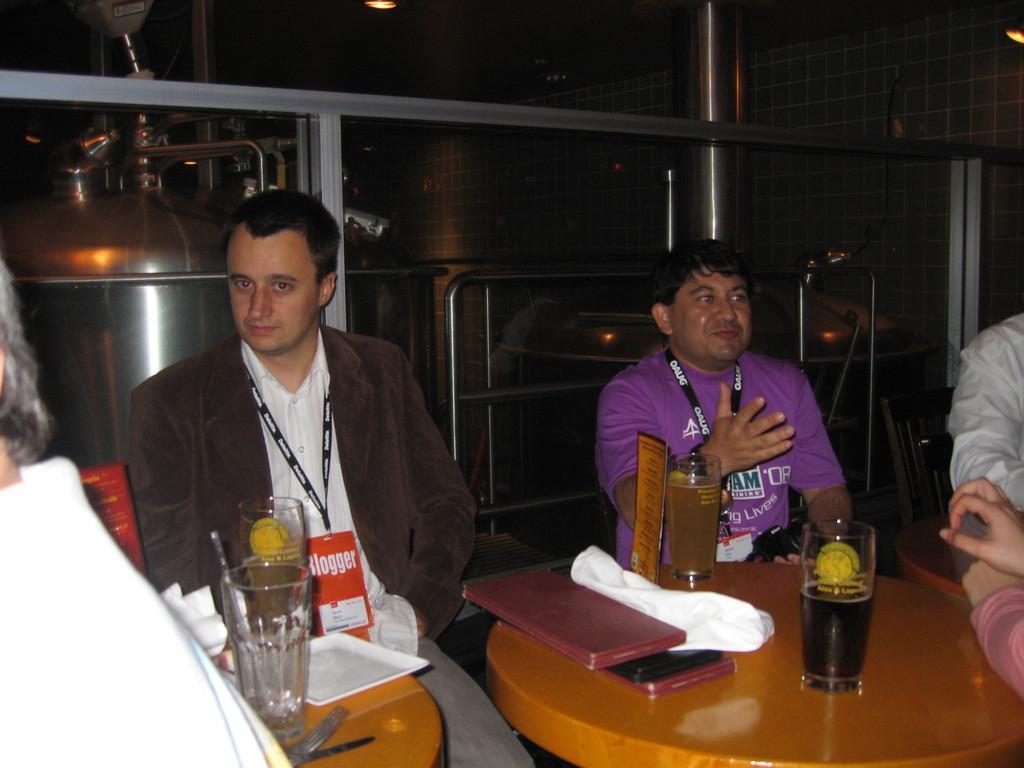Describe this image in one or two sentences. A picture inside of a room. This persons are sitting on a chair. On this tables there are glasses, tray, book and cloth. 